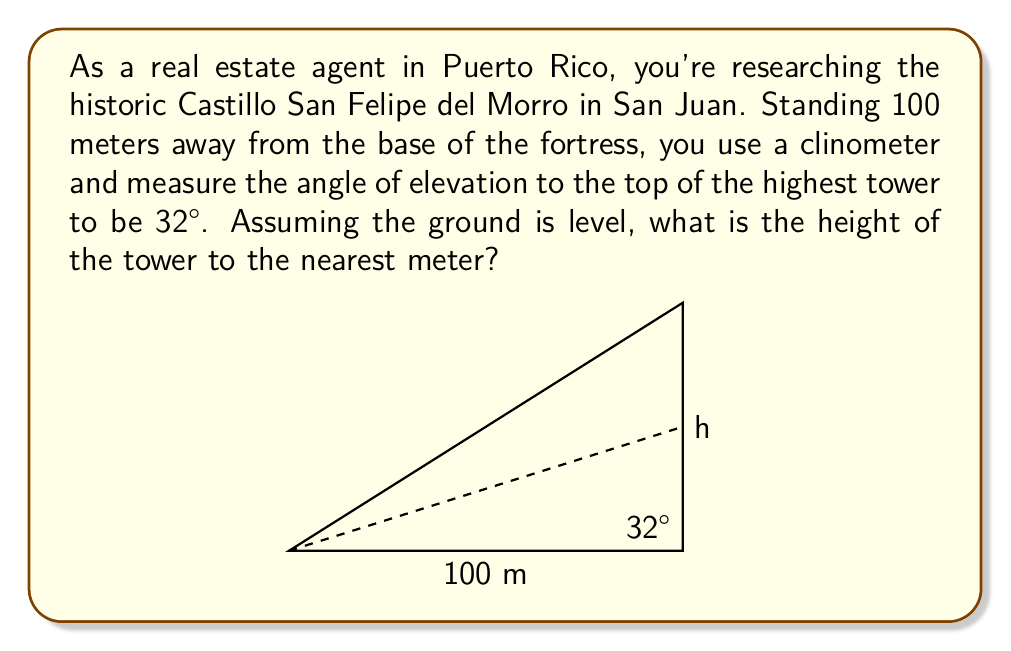Show me your answer to this math problem. To solve this problem, we'll use trigonometry, specifically the tangent function. Here's a step-by-step explanation:

1) In a right triangle, tangent of an angle is the ratio of the opposite side to the adjacent side.

2) In this case:
   - The angle of elevation is 32°
   - The adjacent side is the distance from you to the base of the tower (100 m)
   - The opposite side is the height of the tower we're trying to find

3) Let's call the height $h$. We can set up the equation:

   $$ \tan(32°) = \frac{h}{100} $$

4) To solve for $h$, multiply both sides by 100:

   $$ h = 100 \tan(32°) $$

5) Now we can calculate:
   $$ h = 100 \cdot 0.6249 = 62.49 \text{ meters} $$

6) Rounding to the nearest meter:

   $$ h \approx 62 \text{ meters} $$

Therefore, the height of the tower is approximately 62 meters.
Answer: 62 meters 